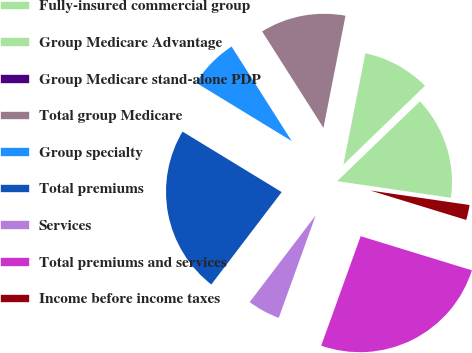<chart> <loc_0><loc_0><loc_500><loc_500><pie_chart><fcel>Fully-insured commercial group<fcel>Group Medicare Advantage<fcel>Group Medicare stand-alone PDP<fcel>Total group Medicare<fcel>Group specialty<fcel>Total premiums<fcel>Services<fcel>Total premiums and services<fcel>Income before income taxes<nl><fcel>14.52%<fcel>9.68%<fcel>0.02%<fcel>12.1%<fcel>7.27%<fcel>23.36%<fcel>4.85%<fcel>25.77%<fcel>2.43%<nl></chart> 